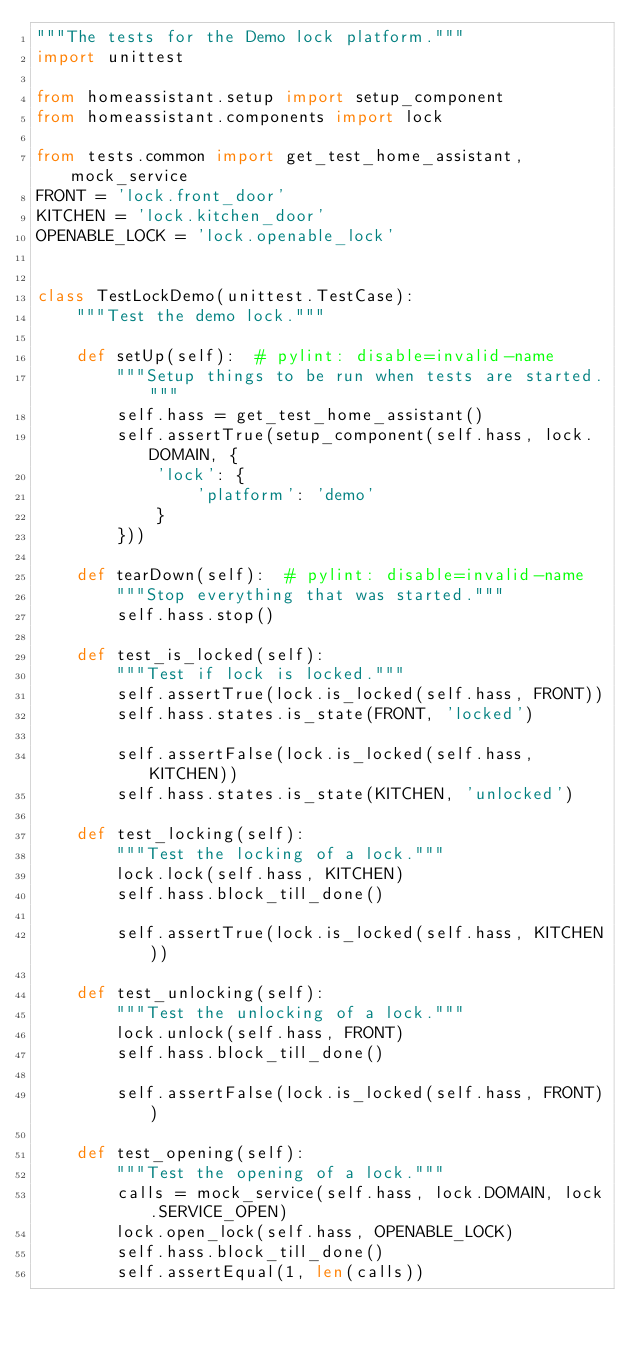Convert code to text. <code><loc_0><loc_0><loc_500><loc_500><_Python_>"""The tests for the Demo lock platform."""
import unittest

from homeassistant.setup import setup_component
from homeassistant.components import lock

from tests.common import get_test_home_assistant, mock_service
FRONT = 'lock.front_door'
KITCHEN = 'lock.kitchen_door'
OPENABLE_LOCK = 'lock.openable_lock'


class TestLockDemo(unittest.TestCase):
    """Test the demo lock."""

    def setUp(self):  # pylint: disable=invalid-name
        """Setup things to be run when tests are started."""
        self.hass = get_test_home_assistant()
        self.assertTrue(setup_component(self.hass, lock.DOMAIN, {
            'lock': {
                'platform': 'demo'
            }
        }))

    def tearDown(self):  # pylint: disable=invalid-name
        """Stop everything that was started."""
        self.hass.stop()

    def test_is_locked(self):
        """Test if lock is locked."""
        self.assertTrue(lock.is_locked(self.hass, FRONT))
        self.hass.states.is_state(FRONT, 'locked')

        self.assertFalse(lock.is_locked(self.hass, KITCHEN))
        self.hass.states.is_state(KITCHEN, 'unlocked')

    def test_locking(self):
        """Test the locking of a lock."""
        lock.lock(self.hass, KITCHEN)
        self.hass.block_till_done()

        self.assertTrue(lock.is_locked(self.hass, KITCHEN))

    def test_unlocking(self):
        """Test the unlocking of a lock."""
        lock.unlock(self.hass, FRONT)
        self.hass.block_till_done()

        self.assertFalse(lock.is_locked(self.hass, FRONT))

    def test_opening(self):
        """Test the opening of a lock."""
        calls = mock_service(self.hass, lock.DOMAIN, lock.SERVICE_OPEN)
        lock.open_lock(self.hass, OPENABLE_LOCK)
        self.hass.block_till_done()
        self.assertEqual(1, len(calls))
</code> 